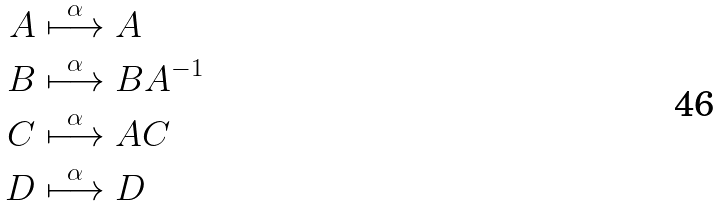Convert formula to latex. <formula><loc_0><loc_0><loc_500><loc_500>A & \stackrel { \alpha } \longmapsto A \\ B & \stackrel { \alpha } \longmapsto B A ^ { - 1 } \\ C & \stackrel { \alpha } \longmapsto A C \\ D & \stackrel { \alpha } \longmapsto D \\</formula> 